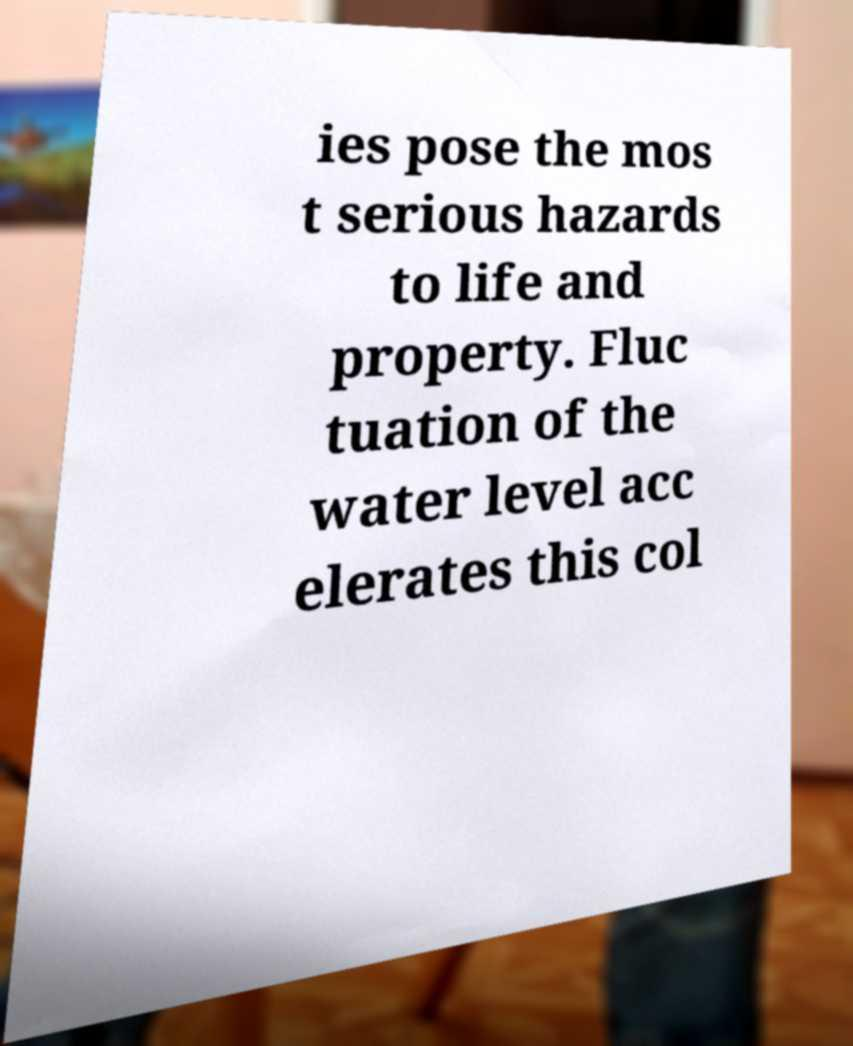Can you accurately transcribe the text from the provided image for me? ies pose the mos t serious hazards to life and property. Fluc tuation of the water level acc elerates this col 